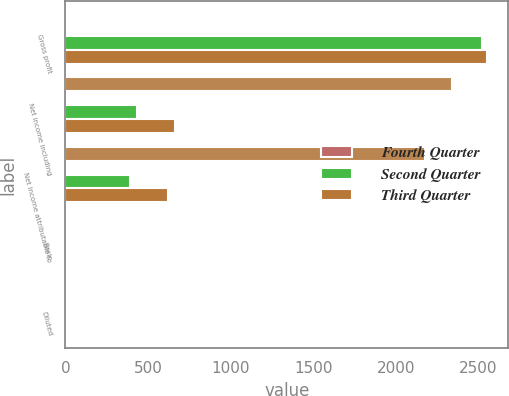Convert chart. <chart><loc_0><loc_0><loc_500><loc_500><stacked_bar_chart><ecel><fcel>Gross profit<fcel>Net income including<fcel>Net income attributable to<fcel>Basic<fcel>Diluted<nl><fcel>nan<fcel>2.36<fcel>2339<fcel>2180<fcel>2.38<fcel>2.36<nl><fcel>Fourth Quarter<fcel>1<fcel>2<fcel>2<fcel>2<fcel>2<nl><fcel>Second Quarter<fcel>2524<fcel>432<fcel>388<fcel>0.42<fcel>0.42<nl><fcel>Third Quarter<fcel>2552<fcel>661<fcel>622<fcel>0.68<fcel>0.67<nl></chart> 